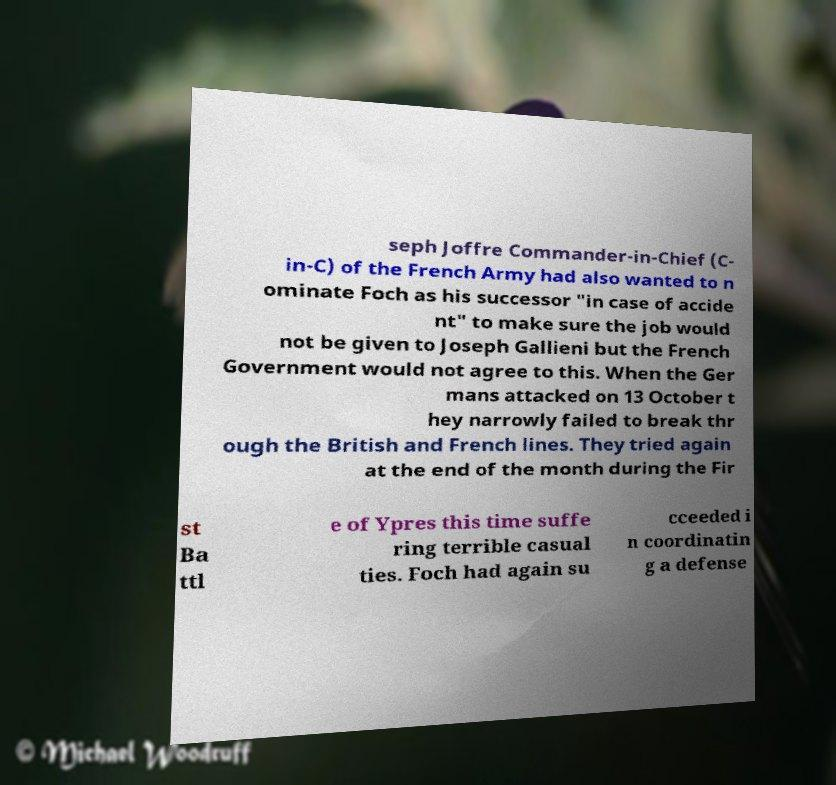There's text embedded in this image that I need extracted. Can you transcribe it verbatim? seph Joffre Commander-in-Chief (C- in-C) of the French Army had also wanted to n ominate Foch as his successor "in case of accide nt" to make sure the job would not be given to Joseph Gallieni but the French Government would not agree to this. When the Ger mans attacked on 13 October t hey narrowly failed to break thr ough the British and French lines. They tried again at the end of the month during the Fir st Ba ttl e of Ypres this time suffe ring terrible casual ties. Foch had again su cceeded i n coordinatin g a defense 